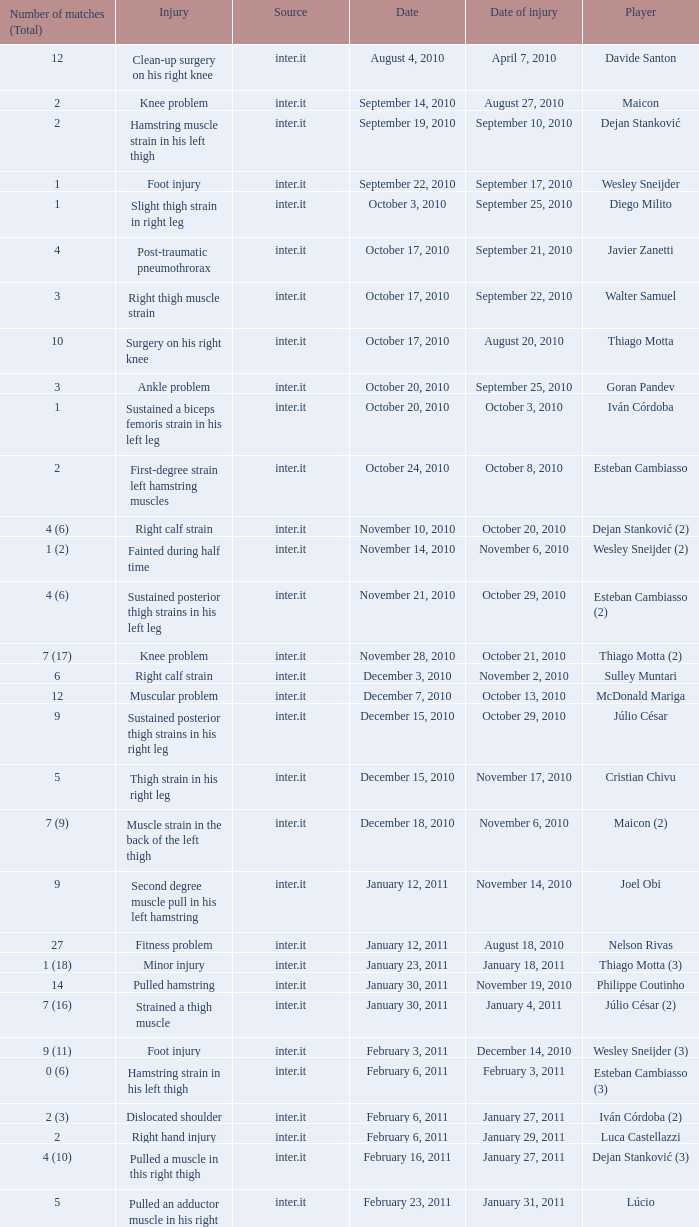What is the date of injury when the injury is sustained posterior thigh strains in his left leg? October 29, 2010. 